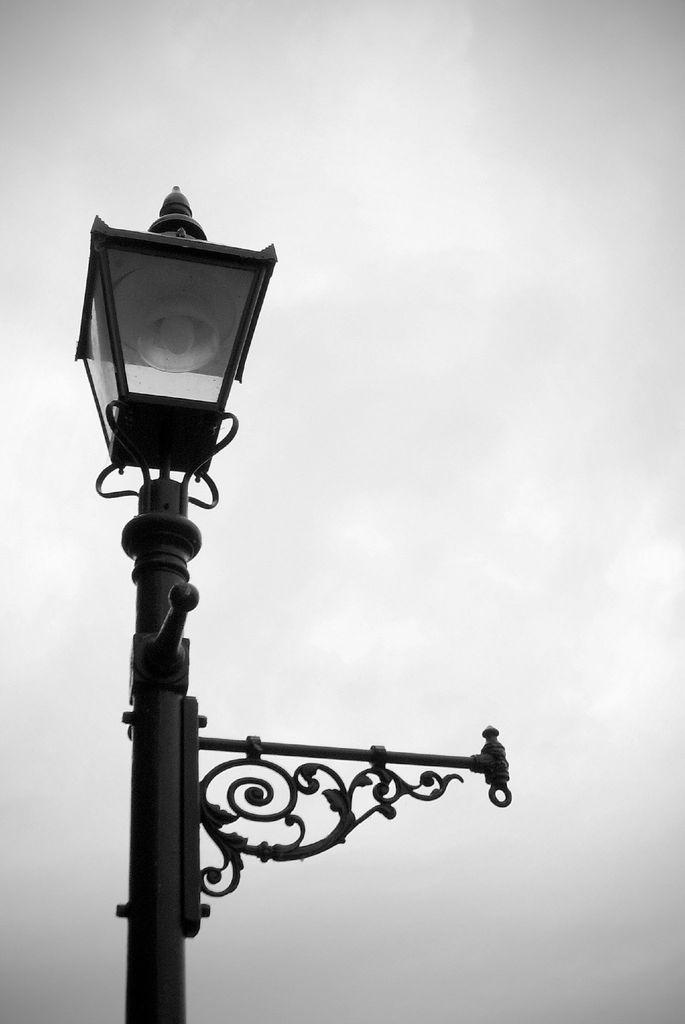What is the main object in the image? There is a lamp post in the image. Where is the lamp post located? The lamp post is on the ground. What is the condition of the sky in the image? The sky is fully covered with clouds in the image. What type of volleyball game is being played in the image? There is no volleyball game present in the image. What is the cause of the cloudy sky in the image? The provided facts do not mention the cause of the cloudy sky, so we cannot determine the cause from the image. 